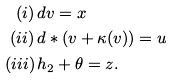<formula> <loc_0><loc_0><loc_500><loc_500>( i ) \, & d v = x \\ ( i i ) \, & d * ( v + \kappa ( v ) ) = u \\ ( i i i ) \, & h _ { 2 } + \theta = z .</formula> 